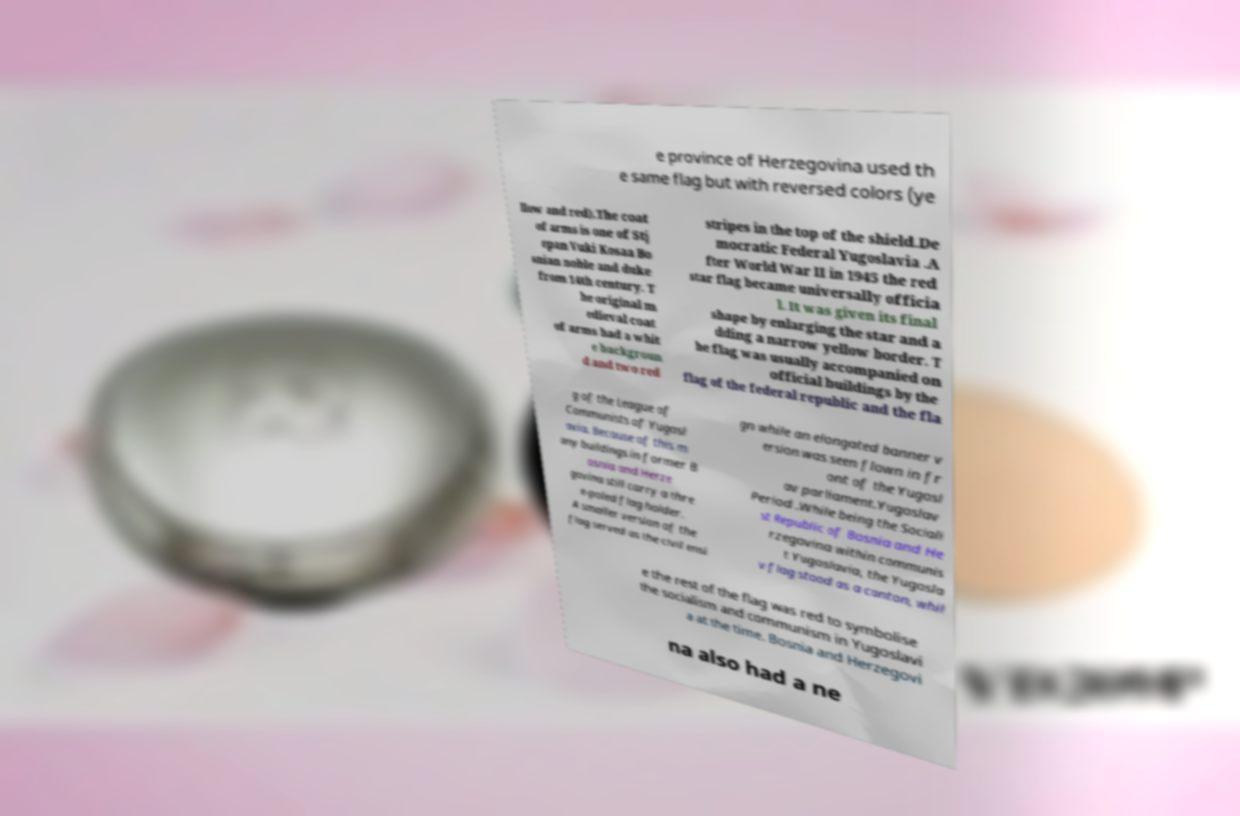I need the written content from this picture converted into text. Can you do that? e province of Herzegovina used th e same flag but with reversed colors (ye llow and red).The coat of arms is one of Stj epan Vuki Kosaa Bo snian noble and duke from 14th century. T he original m edieval coat of arms had a whit e backgroun d and two red stripes in the top of the shield.De mocratic Federal Yugoslavia .A fter World War II in 1945 the red star flag became universally officia l. It was given its final shape by enlarging the star and a dding a narrow yellow border. T he flag was usually accompanied on official buildings by the flag of the federal republic and the fla g of the League of Communists of Yugosl avia. Because of this m any buildings in former B osnia and Herze govina still carry a thre e-poled flag holder. A smaller version of the flag served as the civil ensi gn while an elongated banner v ersion was seen flown in fr ont of the Yugosl av parliament.Yugoslav Period .While being the Sociali st Republic of Bosnia and He rzegovina within communis t Yugoslavia, the Yugosla v flag stood as a canton, whil e the rest of the flag was red to symbolise the socialism and communism in Yugoslavi a at the time. Bosnia and Herzegovi na also had a ne 